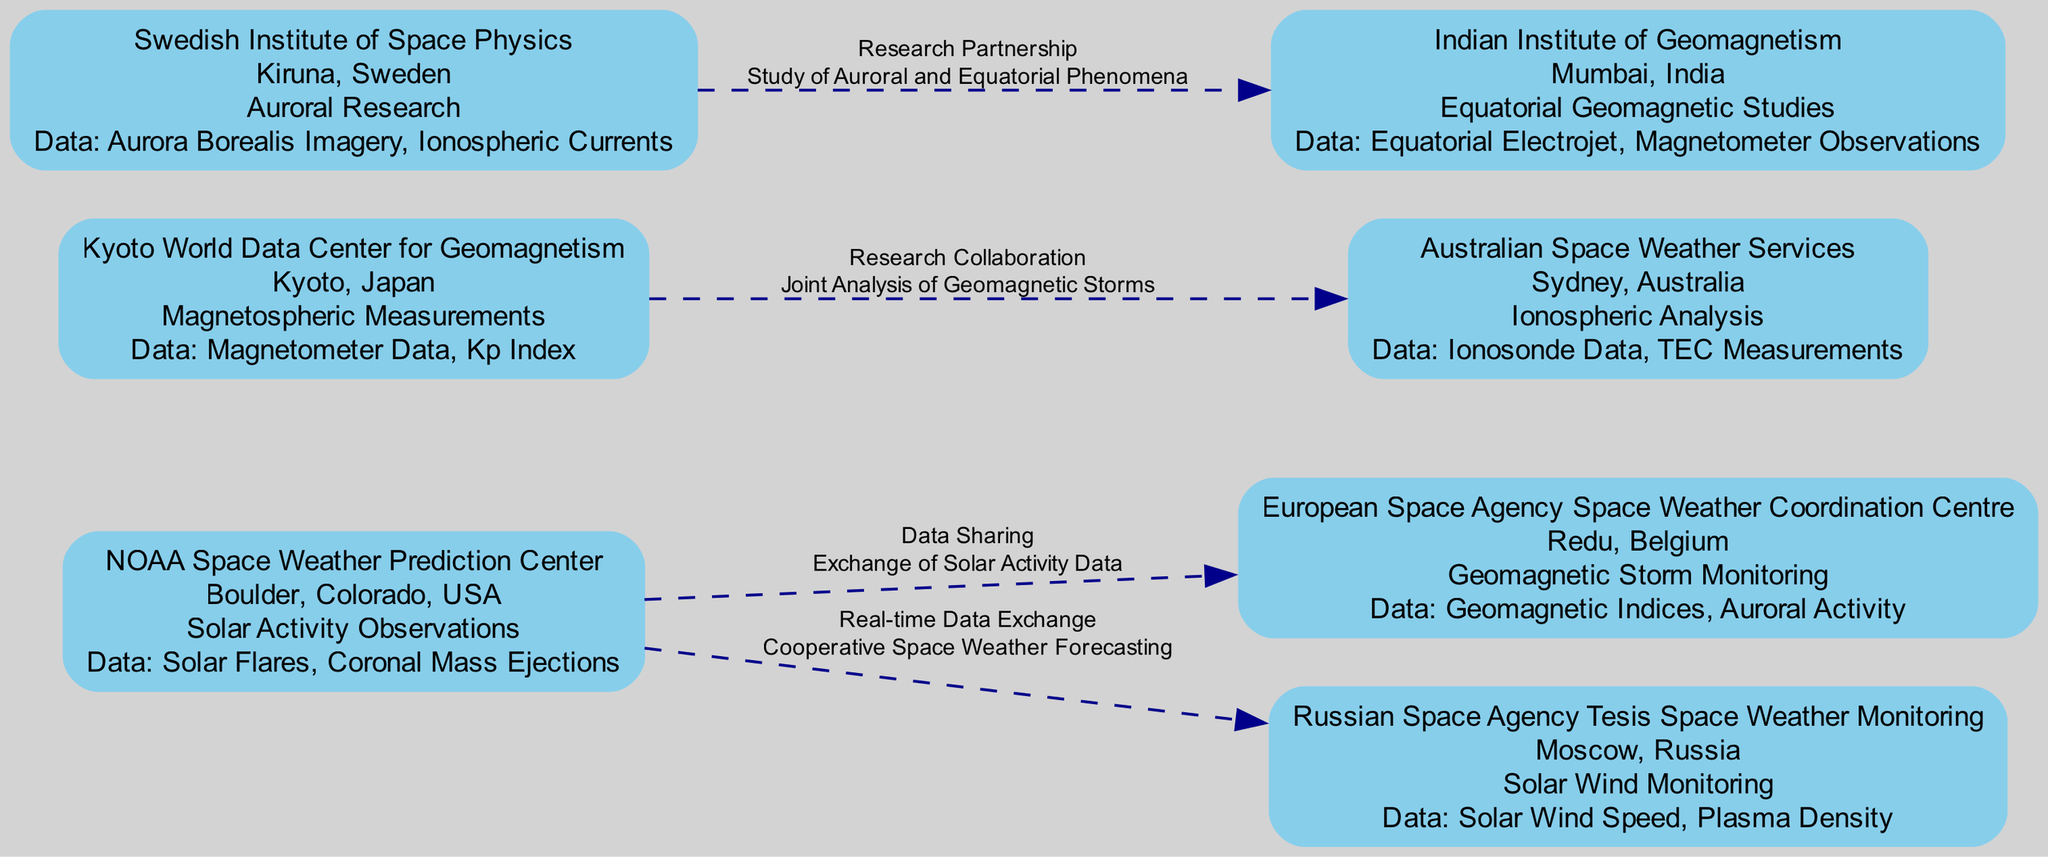What is the location of the Indian Institute of Geomagnetism? The diagram indicates that the Indian Institute of Geomagnetism is located in Mumbai, India.
Answer: Mumbai, India What capability is associated with the NOAA Space Weather Prediction Center? According to the diagram, the NOAA Space Weather Prediction Center has capabilities in Solar Activity Observations.
Answer: Solar Activity Observations How many nodes are represented in the diagram? By counting each of the distinct monitoring stations listed in the diagram, there are a total of seven nodes.
Answer: 7 Which monitoring station specializes in Ionospheric Analysis? The diagram specifies that the Australian Space Weather Services is the station that specializes in Ionospheric Analysis.
Answer: Australian Space Weather Services What data points are monitored by the European Space Agency Space Weather Coordination Centre? The diagram shows that the European Space Agency Space Weather Coordination Centre monitors Geomagnetic Indices and Auroral Activity.
Answer: Geomagnetic Indices, Auroral Activity What is the relationship between the Swedish Institute of Space Physics and the Indian Institute of Geomagnetism? The diagram indicates that there is a Research Partnership between the Swedish Institute of Space Physics and the Indian Institute of Geomagnetism.
Answer: Research Partnership Which two monitoring stations share Solar Activity Data? The diagram illustrates that the NOAA Space Weather Prediction Center shares Solar Activity Data with the European Space Agency Space Weather Coordination Centre.
Answer: NOAA Space Weather Prediction Center, European Space Agency Space Weather Coordination Centre What type of research collaboration is highlighted between Kyoto World Data Center for Geomagnetism and Australian Space Weather Services? The diagram states that the collaboration is focused on Joint Analysis of Geomagnetic Storms.
Answer: Joint Analysis of Geomagnetic Storms 